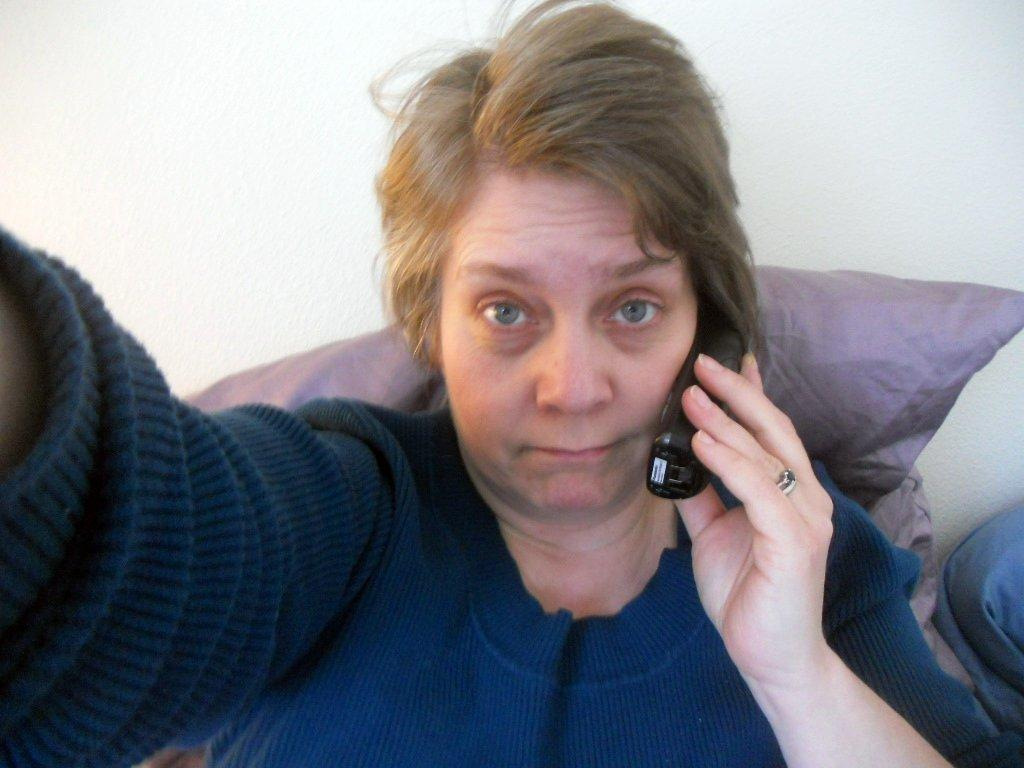Who is present in the image? There is a woman in the image. What is the woman wearing? The woman is wearing clothes. Are there any accessories visible on the woman? Yes, the woman is wearing a finger ring. What is the woman holding in her hand? The woman is holding a mobile phone in her hand. What type of furniture or objects can be seen in the image? There are pillows in the image. What is the background of the image? There is a wall in the image. Can you see a knife being used by the woman in the image? No, there is no knife present in the image. Is the woman giving birth in the image? No, the woman is not giving birth in the image. 